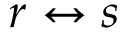Convert formula to latex. <formula><loc_0><loc_0><loc_500><loc_500>r \leftrightarrow s</formula> 